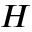Convert formula to latex. <formula><loc_0><loc_0><loc_500><loc_500>H</formula> 